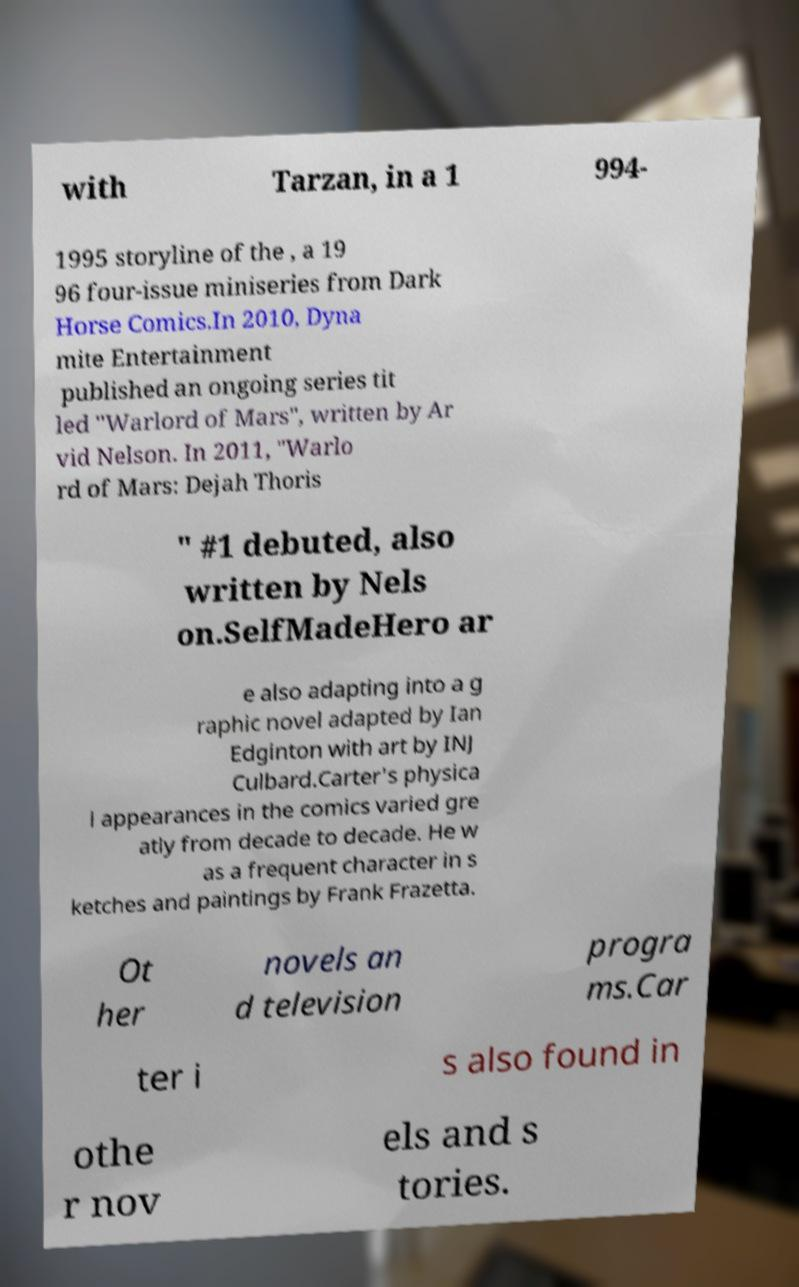Could you extract and type out the text from this image? with Tarzan, in a 1 994- 1995 storyline of the , a 19 96 four-issue miniseries from Dark Horse Comics.In 2010, Dyna mite Entertainment published an ongoing series tit led "Warlord of Mars", written by Ar vid Nelson. In 2011, "Warlo rd of Mars: Dejah Thoris " #1 debuted, also written by Nels on.SelfMadeHero ar e also adapting into a g raphic novel adapted by Ian Edginton with art by INJ Culbard.Carter's physica l appearances in the comics varied gre atly from decade to decade. He w as a frequent character in s ketches and paintings by Frank Frazetta. Ot her novels an d television progra ms.Car ter i s also found in othe r nov els and s tories. 